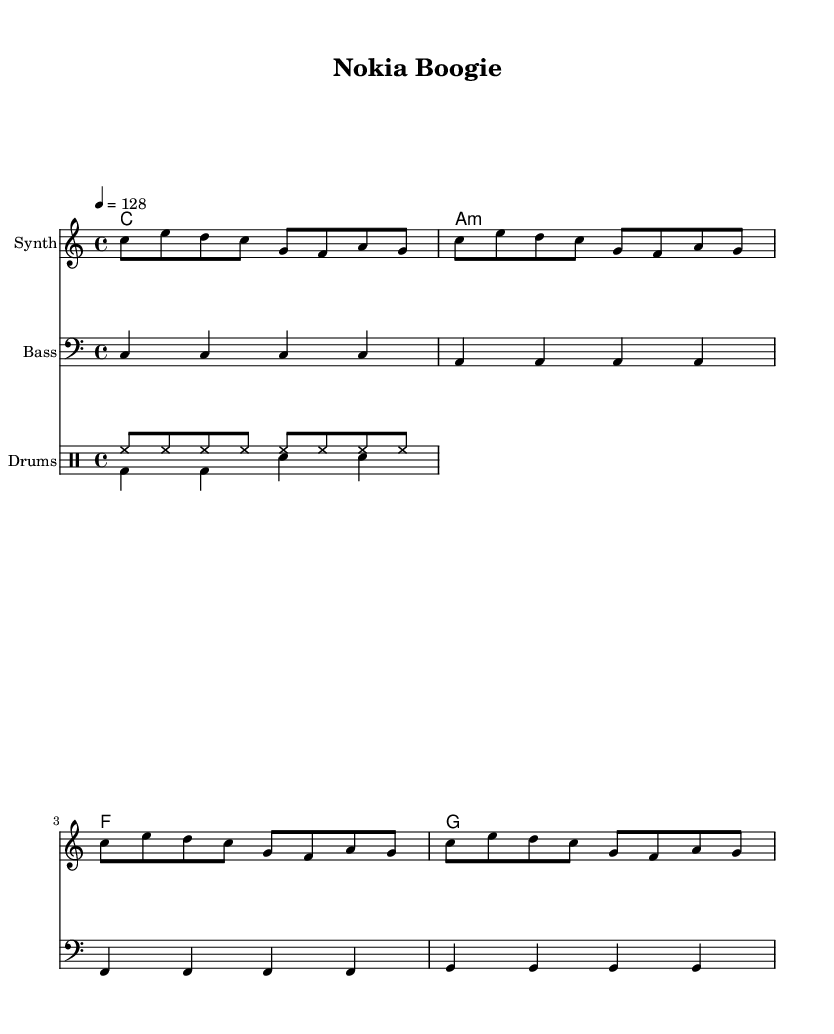What is the key signature of this music? The key signature is C major, which has no sharps or flats.
Answer: C major What is the time signature of this piece? The time signature is indicated as 4/4, meaning there are four beats in a measure.
Answer: 4/4 What is the tempo of this composition? The tempo marking indicates a speed of 128 beats per minute, written as "4 = 128".
Answer: 128 How many measures are in the melody? The melody section consists of 4 measures, as seen by the grouping of notes and the consistent rhythm.
Answer: 4 What is the primary instrument for the melody? The melody is played on a synth, as indicated under the staff labeled "Synth".
Answer: Synth Which chord is played in the first measure? The first measure has the chord C major, which can be confirmed by looking at the chord symbols above the staff.
Answer: C How do the drum patterns contribute to the dance style? The use of high-hat patterns in the 'up' section creates a consistent rhythmic pulse, while the bass drum and snare offer a typical dance beat, all contributing to the upbeat tempo characteristic of dance music.
Answer: Upbeat dance rhythm 